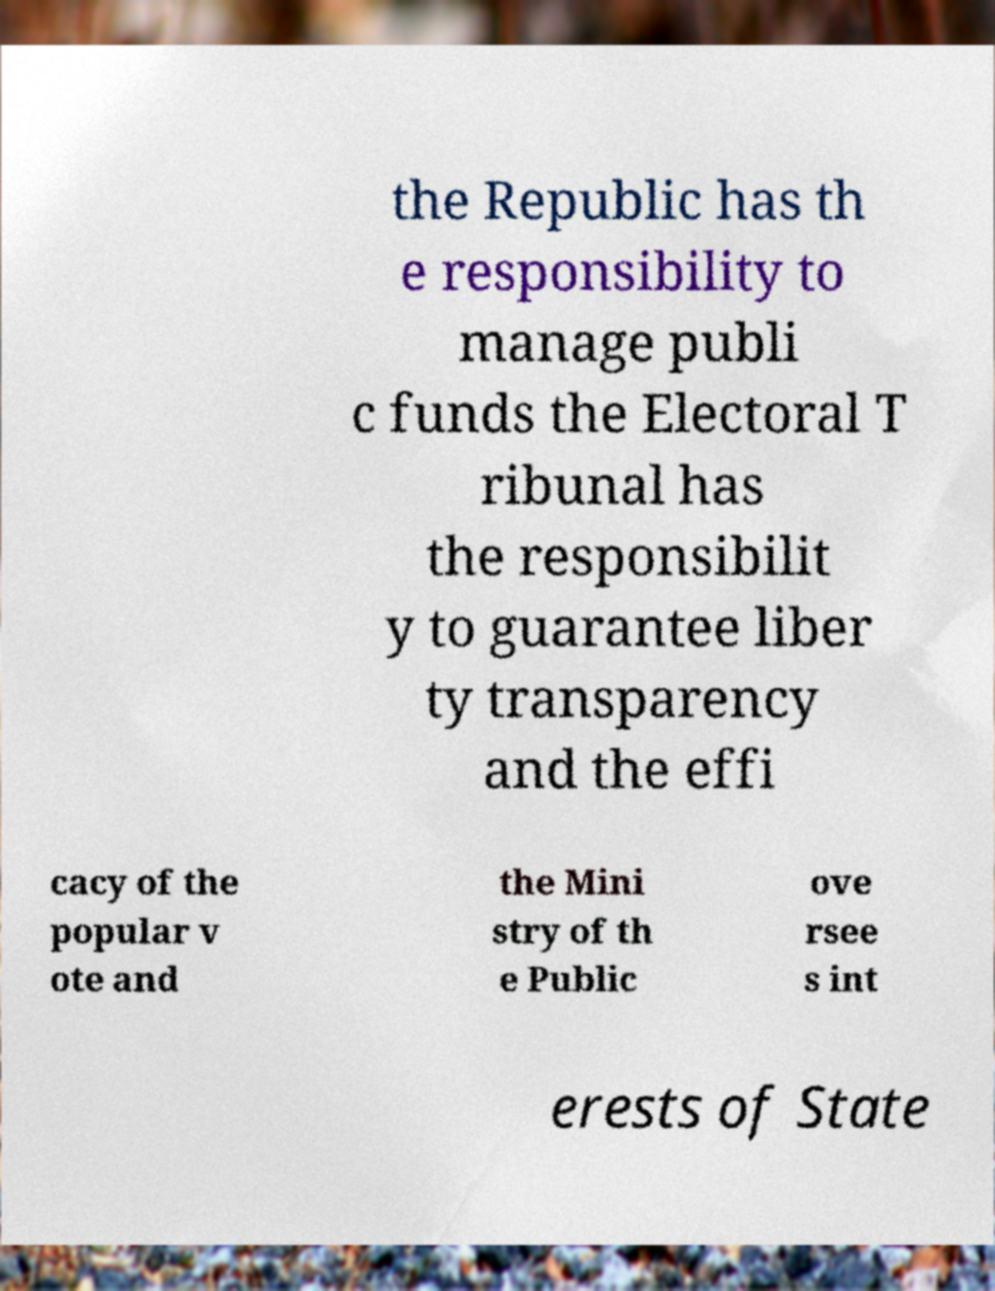I need the written content from this picture converted into text. Can you do that? the Republic has th e responsibility to manage publi c funds the Electoral T ribunal has the responsibilit y to guarantee liber ty transparency and the effi cacy of the popular v ote and the Mini stry of th e Public ove rsee s int erests of State 